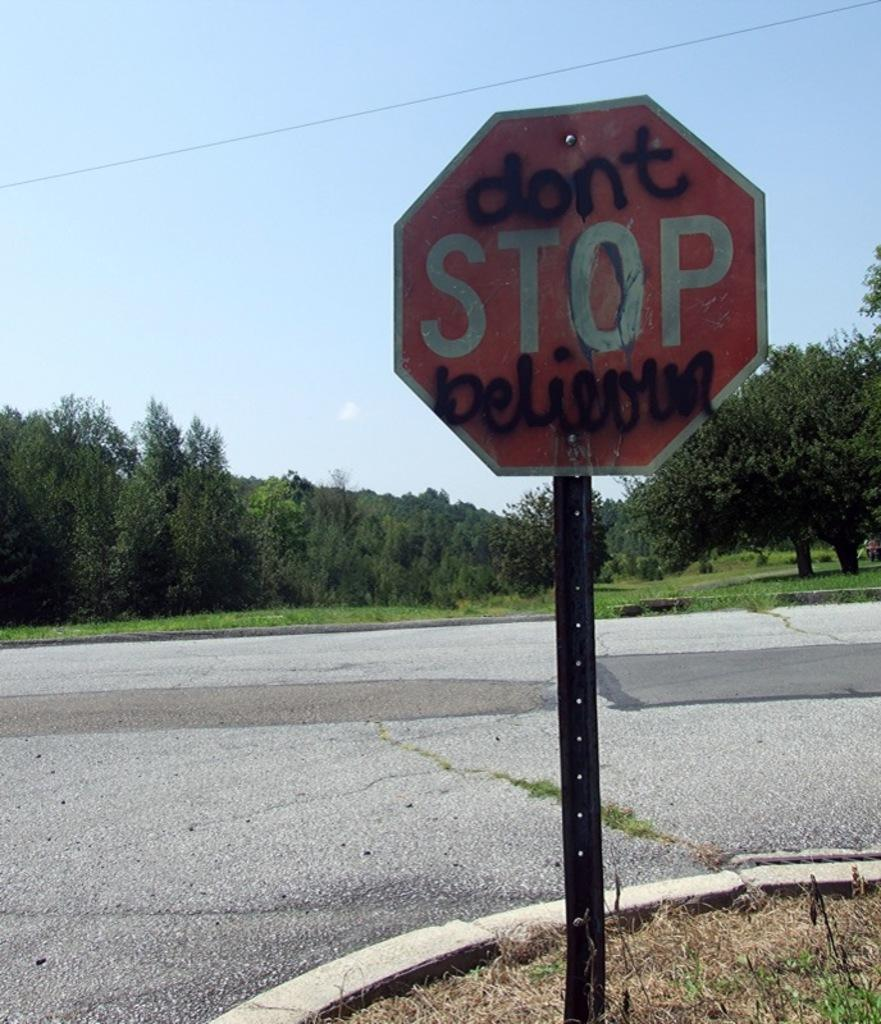<image>
Present a compact description of the photo's key features. a stop sign that is red and white and outside 